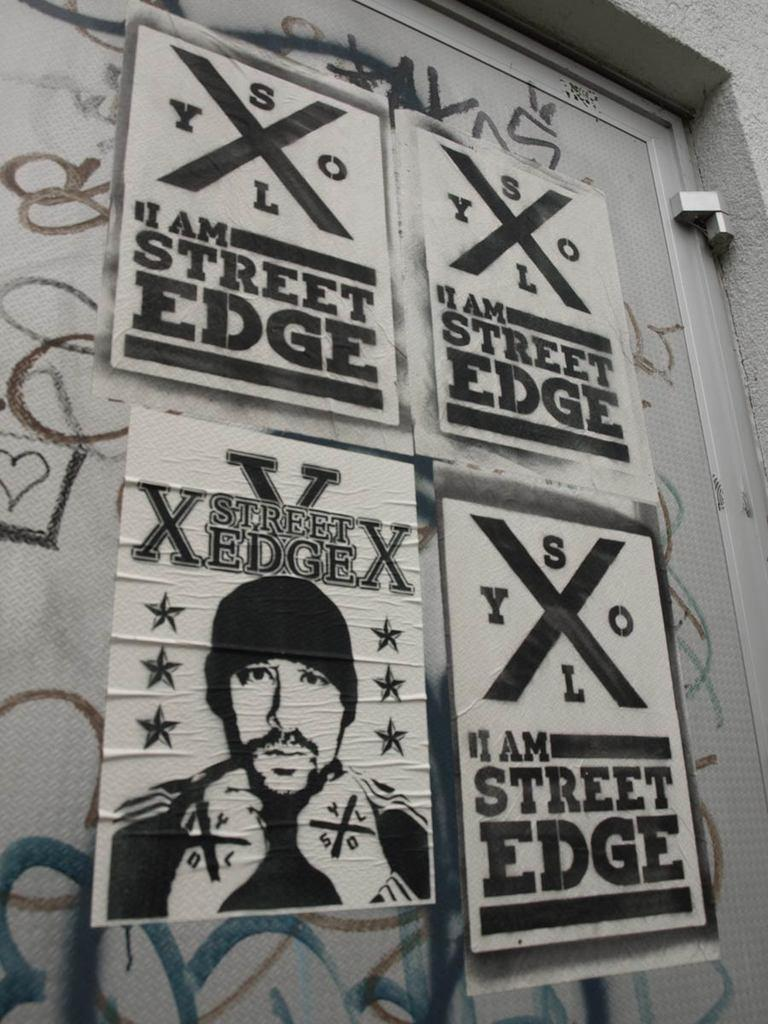What is the main subject in the center of the image? There is a door in the center of the image. What decorations are on the door? There are pictures and text on the door. What can be seen behind the door in the image? There is a wall visible in the background of the image. What type of wine is being served at the society event in the image? There is no society event or wine present in the image; it features a door with pictures and text. 